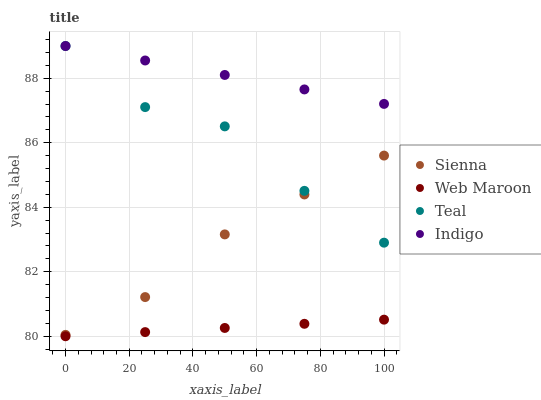Does Web Maroon have the minimum area under the curve?
Answer yes or no. Yes. Does Indigo have the maximum area under the curve?
Answer yes or no. Yes. Does Indigo have the minimum area under the curve?
Answer yes or no. No. Does Web Maroon have the maximum area under the curve?
Answer yes or no. No. Is Indigo the smoothest?
Answer yes or no. Yes. Is Teal the roughest?
Answer yes or no. Yes. Is Web Maroon the smoothest?
Answer yes or no. No. Is Web Maroon the roughest?
Answer yes or no. No. Does Web Maroon have the lowest value?
Answer yes or no. Yes. Does Indigo have the lowest value?
Answer yes or no. No. Does Teal have the highest value?
Answer yes or no. Yes. Does Web Maroon have the highest value?
Answer yes or no. No. Is Web Maroon less than Indigo?
Answer yes or no. Yes. Is Indigo greater than Sienna?
Answer yes or no. Yes. Does Sienna intersect Teal?
Answer yes or no. Yes. Is Sienna less than Teal?
Answer yes or no. No. Is Sienna greater than Teal?
Answer yes or no. No. Does Web Maroon intersect Indigo?
Answer yes or no. No. 